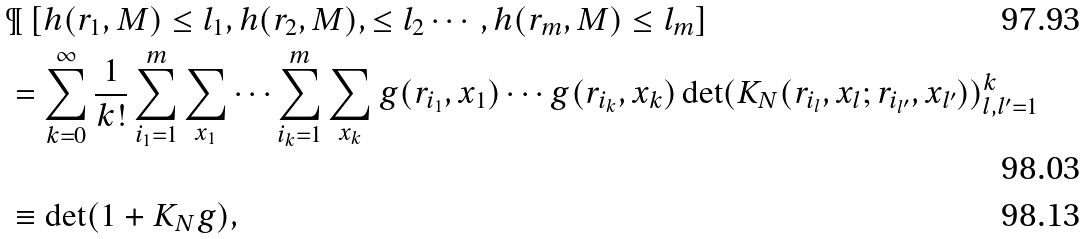<formula> <loc_0><loc_0><loc_500><loc_500>& \P \left [ h ( r _ { 1 } , M ) \leq l _ { 1 } , h ( r _ { 2 } , M ) , \leq l _ { 2 } \cdots , h ( r _ { m } , M ) \leq l _ { m } \right ] \\ & = \sum _ { k = 0 } ^ { \infty } \frac { 1 } { k ! } \sum _ { i _ { 1 } = 1 } ^ { m } \sum _ { x _ { 1 } } \cdots \sum _ { i _ { k } = 1 } ^ { m } \sum _ { x _ { k } } g ( r _ { i _ { 1 } } , x _ { 1 } ) \cdots g ( r _ { i _ { k } } , x _ { k } ) \det ( K _ { N } ( r _ { i _ { l } } , x _ { l } ; r _ { i _ { l ^ { \prime } } } , x _ { l ^ { \prime } } ) ) _ { l , l ^ { \prime } = 1 } ^ { k } \\ & \equiv \det ( 1 + K _ { N } g ) ,</formula> 